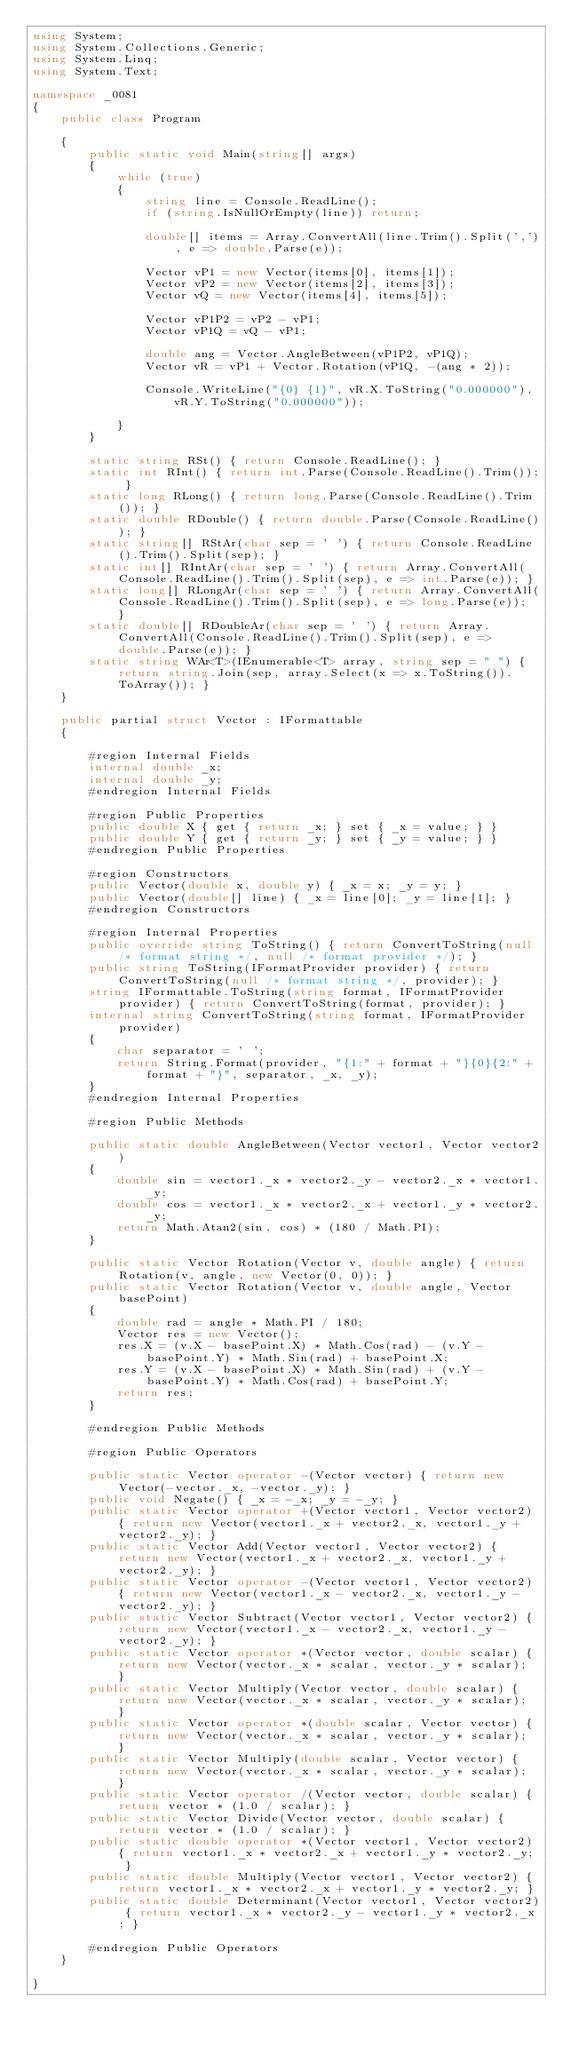<code> <loc_0><loc_0><loc_500><loc_500><_C#_>using System;
using System.Collections.Generic;
using System.Linq;
using System.Text;

namespace _0081
{
    public class Program

    {
        public static void Main(string[] args)
        {
            while (true)
            {
                string line = Console.ReadLine();
                if (string.IsNullOrEmpty(line)) return;

                double[] items = Array.ConvertAll(line.Trim().Split(','), e => double.Parse(e));

                Vector vP1 = new Vector(items[0], items[1]);
                Vector vP2 = new Vector(items[2], items[3]);
                Vector vQ = new Vector(items[4], items[5]);

                Vector vP1P2 = vP2 - vP1;
                Vector vP1Q = vQ - vP1;

                double ang = Vector.AngleBetween(vP1P2, vP1Q);
                Vector vR = vP1 + Vector.Rotation(vP1Q, -(ang * 2));

                Console.WriteLine("{0} {1}", vR.X.ToString("0.000000"), vR.Y.ToString("0.000000"));

            }
        }

        static string RSt() { return Console.ReadLine(); }
        static int RInt() { return int.Parse(Console.ReadLine().Trim()); }
        static long RLong() { return long.Parse(Console.ReadLine().Trim()); }
        static double RDouble() { return double.Parse(Console.ReadLine()); }
        static string[] RStAr(char sep = ' ') { return Console.ReadLine().Trim().Split(sep); }
        static int[] RIntAr(char sep = ' ') { return Array.ConvertAll(Console.ReadLine().Trim().Split(sep), e => int.Parse(e)); }
        static long[] RLongAr(char sep = ' ') { return Array.ConvertAll(Console.ReadLine().Trim().Split(sep), e => long.Parse(e)); }
        static double[] RDoubleAr(char sep = ' ') { return Array.ConvertAll(Console.ReadLine().Trim().Split(sep), e => double.Parse(e)); }
        static string WAr<T>(IEnumerable<T> array, string sep = " ") { return string.Join(sep, array.Select(x => x.ToString()).ToArray()); }
    }

    public partial struct Vector : IFormattable
    {

        #region Internal Fields	
        internal double _x;
        internal double _y;
        #endregion Internal Fields	

        #region Public Properties	
        public double X { get { return _x; } set { _x = value; } }
        public double Y { get { return _y; } set { _y = value; } }
        #endregion Public Properties

        #region Constructors
        public Vector(double x, double y) { _x = x; _y = y; }
        public Vector(double[] line) { _x = line[0]; _y = line[1]; }
        #endregion Constructors

        #region Internal Properties	
        public override string ToString() { return ConvertToString(null /* format string */, null /* format provider */); }
        public string ToString(IFormatProvider provider) { return ConvertToString(null /* format string */, provider); }
        string IFormattable.ToString(string format, IFormatProvider provider) { return ConvertToString(format, provider); }
        internal string ConvertToString(string format, IFormatProvider provider)
        {
            char separator = ' ';
            return String.Format(provider, "{1:" + format + "}{0}{2:" + format + "}", separator, _x, _y);
        }
        #endregion Internal Properties	

        #region Public Methods

        public static double AngleBetween(Vector vector1, Vector vector2)
        {
            double sin = vector1._x * vector2._y - vector2._x * vector1._y;
            double cos = vector1._x * vector2._x + vector1._y * vector2._y;
            return Math.Atan2(sin, cos) * (180 / Math.PI);
        }

        public static Vector Rotation(Vector v, double angle) { return Rotation(v, angle, new Vector(0, 0)); }
        public static Vector Rotation(Vector v, double angle, Vector basePoint)
        {
            double rad = angle * Math.PI / 180;
            Vector res = new Vector();
            res.X = (v.X - basePoint.X) * Math.Cos(rad) - (v.Y - basePoint.Y) * Math.Sin(rad) + basePoint.X;
            res.Y = (v.X - basePoint.X) * Math.Sin(rad) + (v.Y - basePoint.Y) * Math.Cos(rad) + basePoint.Y;
            return res;
        }

        #endregion Public Methods

        #region Public Operators

        public static Vector operator -(Vector vector) { return new Vector(-vector._x, -vector._y); }
        public void Negate() { _x = -_x; _y = -_y; }
        public static Vector operator +(Vector vector1, Vector vector2) { return new Vector(vector1._x + vector2._x, vector1._y + vector2._y); }
        public static Vector Add(Vector vector1, Vector vector2) { return new Vector(vector1._x + vector2._x, vector1._y + vector2._y); }
        public static Vector operator -(Vector vector1, Vector vector2) { return new Vector(vector1._x - vector2._x, vector1._y - vector2._y); }
        public static Vector Subtract(Vector vector1, Vector vector2) { return new Vector(vector1._x - vector2._x, vector1._y - vector2._y); }
        public static Vector operator *(Vector vector, double scalar) { return new Vector(vector._x * scalar, vector._y * scalar); }
        public static Vector Multiply(Vector vector, double scalar) { return new Vector(vector._x * scalar, vector._y * scalar); }
        public static Vector operator *(double scalar, Vector vector) { return new Vector(vector._x * scalar, vector._y * scalar); }
        public static Vector Multiply(double scalar, Vector vector) { return new Vector(vector._x * scalar, vector._y * scalar); }
        public static Vector operator /(Vector vector, double scalar) { return vector * (1.0 / scalar); }
        public static Vector Divide(Vector vector, double scalar) { return vector * (1.0 / scalar); }
        public static double operator *(Vector vector1, Vector vector2) { return vector1._x * vector2._x + vector1._y * vector2._y; }
        public static double Multiply(Vector vector1, Vector vector2) { return vector1._x * vector2._x + vector1._y * vector2._y; }
        public static double Determinant(Vector vector1, Vector vector2) { return vector1._x * vector2._y - vector1._y * vector2._x; }

        #endregion Public Operators
    }

}

</code> 